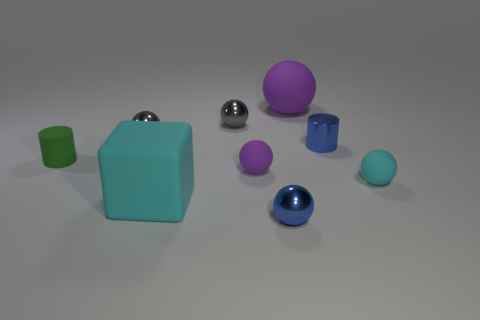Is there any other thing that has the same shape as the large cyan object?
Your answer should be compact. No. How many small cyan matte spheres are right of the cyan rubber ball?
Your response must be concise. 0. What is the shape of the large thing in front of the big purple rubber thing left of the small cyan ball?
Give a very brief answer. Cube. There is a purple thing that is the same material as the tiny purple ball; what is its shape?
Your answer should be very brief. Sphere. Do the purple object that is in front of the green object and the blue shiny object that is behind the small cyan thing have the same size?
Offer a very short reply. Yes. What is the shape of the large object behind the large rubber block?
Provide a short and direct response. Sphere. The shiny cylinder is what color?
Keep it short and to the point. Blue. There is a cyan matte block; does it have the same size as the purple object that is behind the green rubber thing?
Offer a very short reply. Yes. How many metallic objects are either gray spheres or big cyan cubes?
Give a very brief answer. 2. Are there any other things that have the same material as the green thing?
Offer a terse response. Yes. 